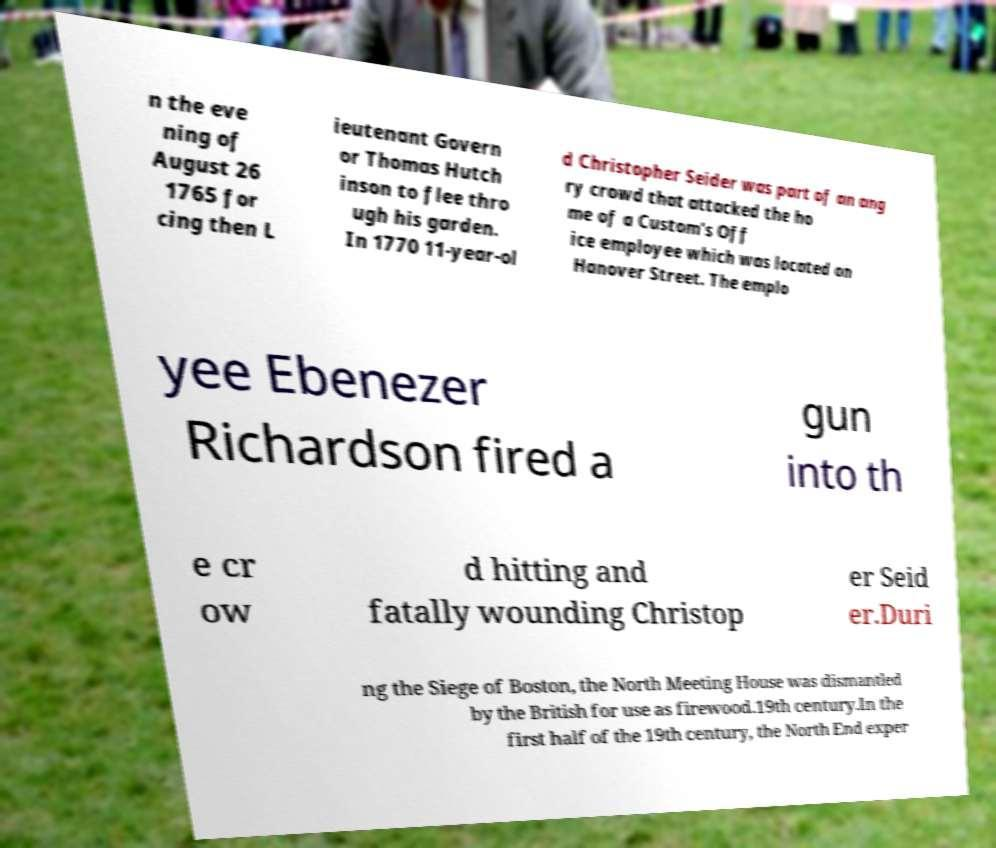Please identify and transcribe the text found in this image. n the eve ning of August 26 1765 for cing then L ieutenant Govern or Thomas Hutch inson to flee thro ugh his garden. In 1770 11-year-ol d Christopher Seider was part of an ang ry crowd that attacked the ho me of a Custom's Off ice employee which was located on Hanover Street. The emplo yee Ebenezer Richardson fired a gun into th e cr ow d hitting and fatally wounding Christop er Seid er.Duri ng the Siege of Boston, the North Meeting House was dismantled by the British for use as firewood.19th century.In the first half of the 19th century, the North End exper 